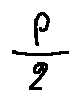<formula> <loc_0><loc_0><loc_500><loc_500>\frac { p } { 2 }</formula> 